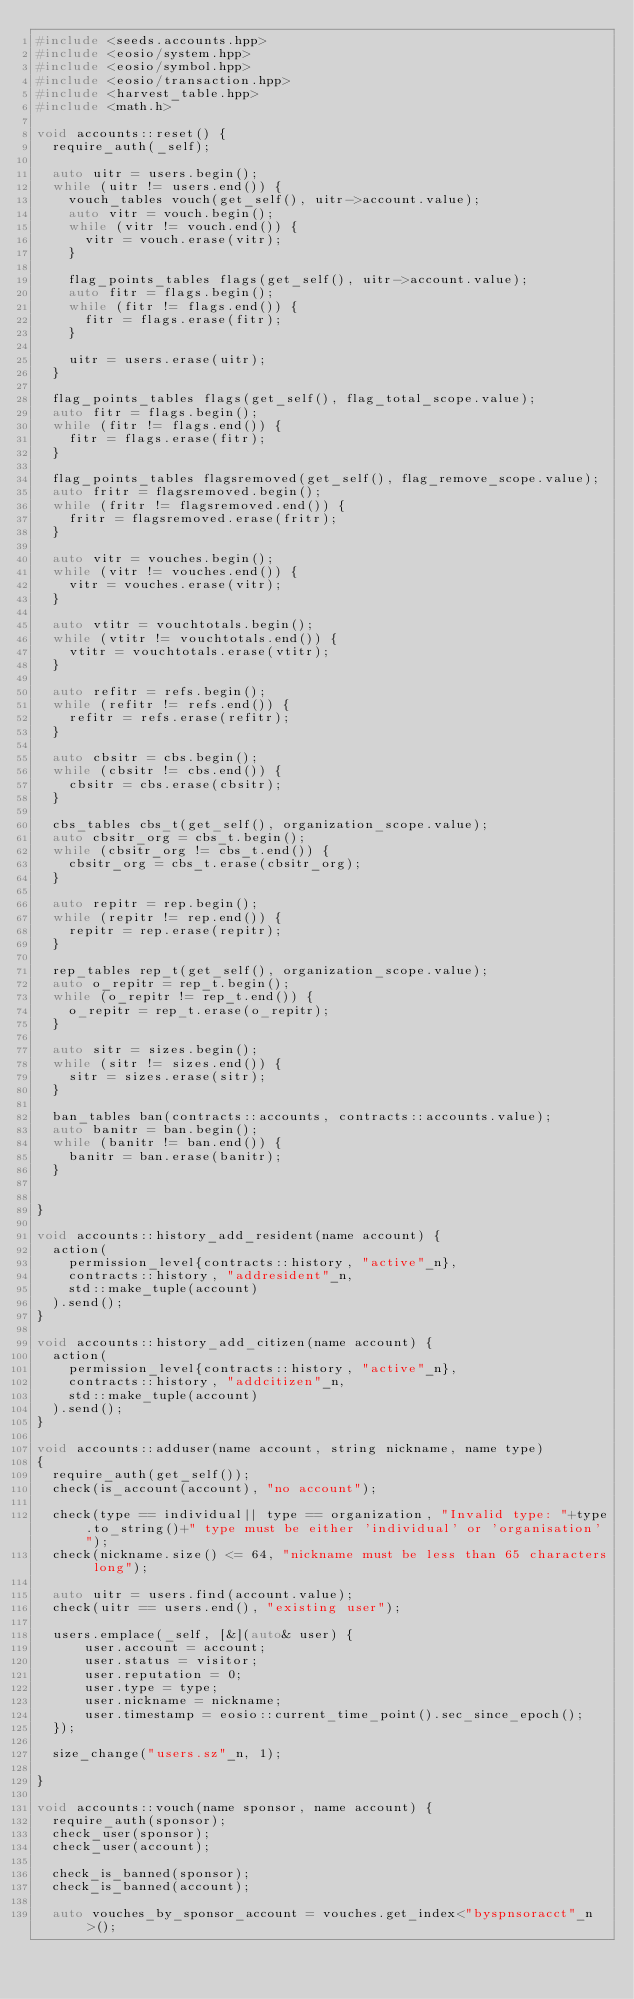<code> <loc_0><loc_0><loc_500><loc_500><_C++_>#include <seeds.accounts.hpp>
#include <eosio/system.hpp>
#include <eosio/symbol.hpp>
#include <eosio/transaction.hpp>
#include <harvest_table.hpp>
#include <math.h>

void accounts::reset() {
  require_auth(_self);

  auto uitr = users.begin();
  while (uitr != users.end()) {
    vouch_tables vouch(get_self(), uitr->account.value);
    auto vitr = vouch.begin();
    while (vitr != vouch.end()) {
      vitr = vouch.erase(vitr);
    }

    flag_points_tables flags(get_self(), uitr->account.value);
    auto fitr = flags.begin();
    while (fitr != flags.end()) {
      fitr = flags.erase(fitr);
    }

    uitr = users.erase(uitr);
  }

  flag_points_tables flags(get_self(), flag_total_scope.value);
  auto fitr = flags.begin();
  while (fitr != flags.end()) {
    fitr = flags.erase(fitr);
  }

  flag_points_tables flagsremoved(get_self(), flag_remove_scope.value);
  auto fritr = flagsremoved.begin();
  while (fritr != flagsremoved.end()) {
    fritr = flagsremoved.erase(fritr);
  }

  auto vitr = vouches.begin();
  while (vitr != vouches.end()) {
    vitr = vouches.erase(vitr);
  }

  auto vtitr = vouchtotals.begin();
  while (vtitr != vouchtotals.end()) {
    vtitr = vouchtotals.erase(vtitr);
  }

  auto refitr = refs.begin();
  while (refitr != refs.end()) {
    refitr = refs.erase(refitr);
  }

  auto cbsitr = cbs.begin();
  while (cbsitr != cbs.end()) {
    cbsitr = cbs.erase(cbsitr);
  }

  cbs_tables cbs_t(get_self(), organization_scope.value);
  auto cbsitr_org = cbs_t.begin();
  while (cbsitr_org != cbs_t.end()) {
    cbsitr_org = cbs_t.erase(cbsitr_org);
  }

  auto repitr = rep.begin();
  while (repitr != rep.end()) {
    repitr = rep.erase(repitr);
  }

  rep_tables rep_t(get_self(), organization_scope.value);
  auto o_repitr = rep_t.begin();
  while (o_repitr != rep_t.end()) {
    o_repitr = rep_t.erase(o_repitr);
  }

  auto sitr = sizes.begin();
  while (sitr != sizes.end()) {
    sitr = sizes.erase(sitr);
  }

  ban_tables ban(contracts::accounts, contracts::accounts.value);
  auto banitr = ban.begin();
  while (banitr != ban.end()) {
    banitr = ban.erase(banitr);
  }


}

void accounts::history_add_resident(name account) {
  action(
    permission_level{contracts::history, "active"_n},
    contracts::history, "addresident"_n,
    std::make_tuple(account)
  ).send();
}

void accounts::history_add_citizen(name account) {
  action(
    permission_level{contracts::history, "active"_n},
    contracts::history, "addcitizen"_n,
    std::make_tuple(account)
  ).send();
}

void accounts::adduser(name account, string nickname, name type)
{
  require_auth(get_self());
  check(is_account(account), "no account");

  check(type == individual|| type == organization, "Invalid type: "+type.to_string()+" type must be either 'individual' or 'organisation'");
  check(nickname.size() <= 64, "nickname must be less than 65 characters long");

  auto uitr = users.find(account.value);
  check(uitr == users.end(), "existing user");

  users.emplace(_self, [&](auto& user) {
      user.account = account;
      user.status = visitor;
      user.reputation = 0;
      user.type = type;
      user.nickname = nickname;
      user.timestamp = eosio::current_time_point().sec_since_epoch();
  });

  size_change("users.sz"_n, 1);

}

void accounts::vouch(name sponsor, name account) {
  require_auth(sponsor);
  check_user(sponsor);
  check_user(account);

  check_is_banned(sponsor);
  check_is_banned(account);

  auto vouches_by_sponsor_account = vouches.get_index<"byspnsoracct"_n>();</code> 